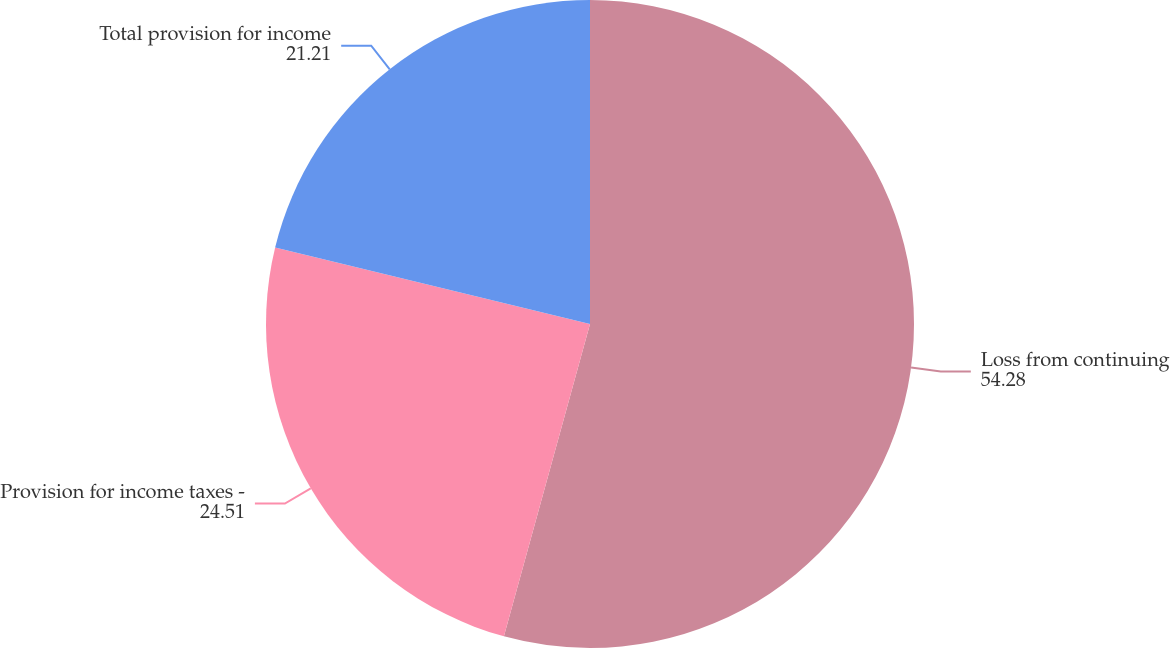Convert chart. <chart><loc_0><loc_0><loc_500><loc_500><pie_chart><fcel>Loss from continuing<fcel>Provision for income taxes -<fcel>Total provision for income<nl><fcel>54.28%<fcel>24.51%<fcel>21.21%<nl></chart> 